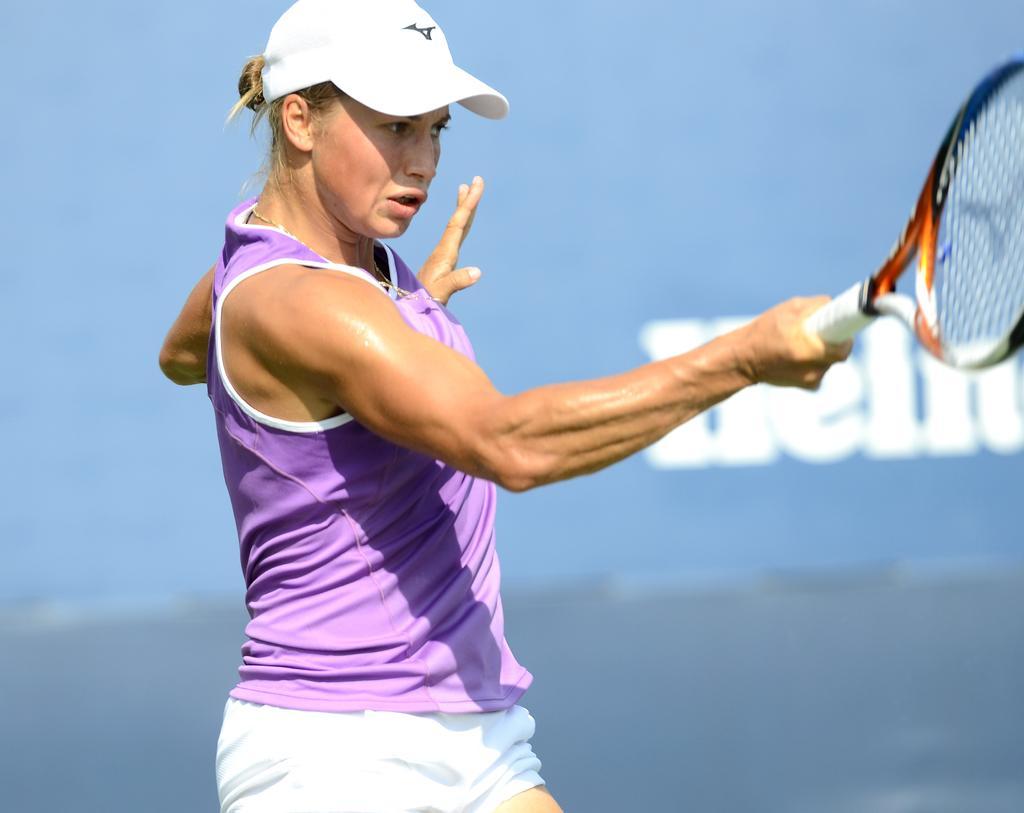How would you summarize this image in a sentence or two? In this image we can see a woman with sports uniform is holding a tennis racket and a wall with text in the background. 